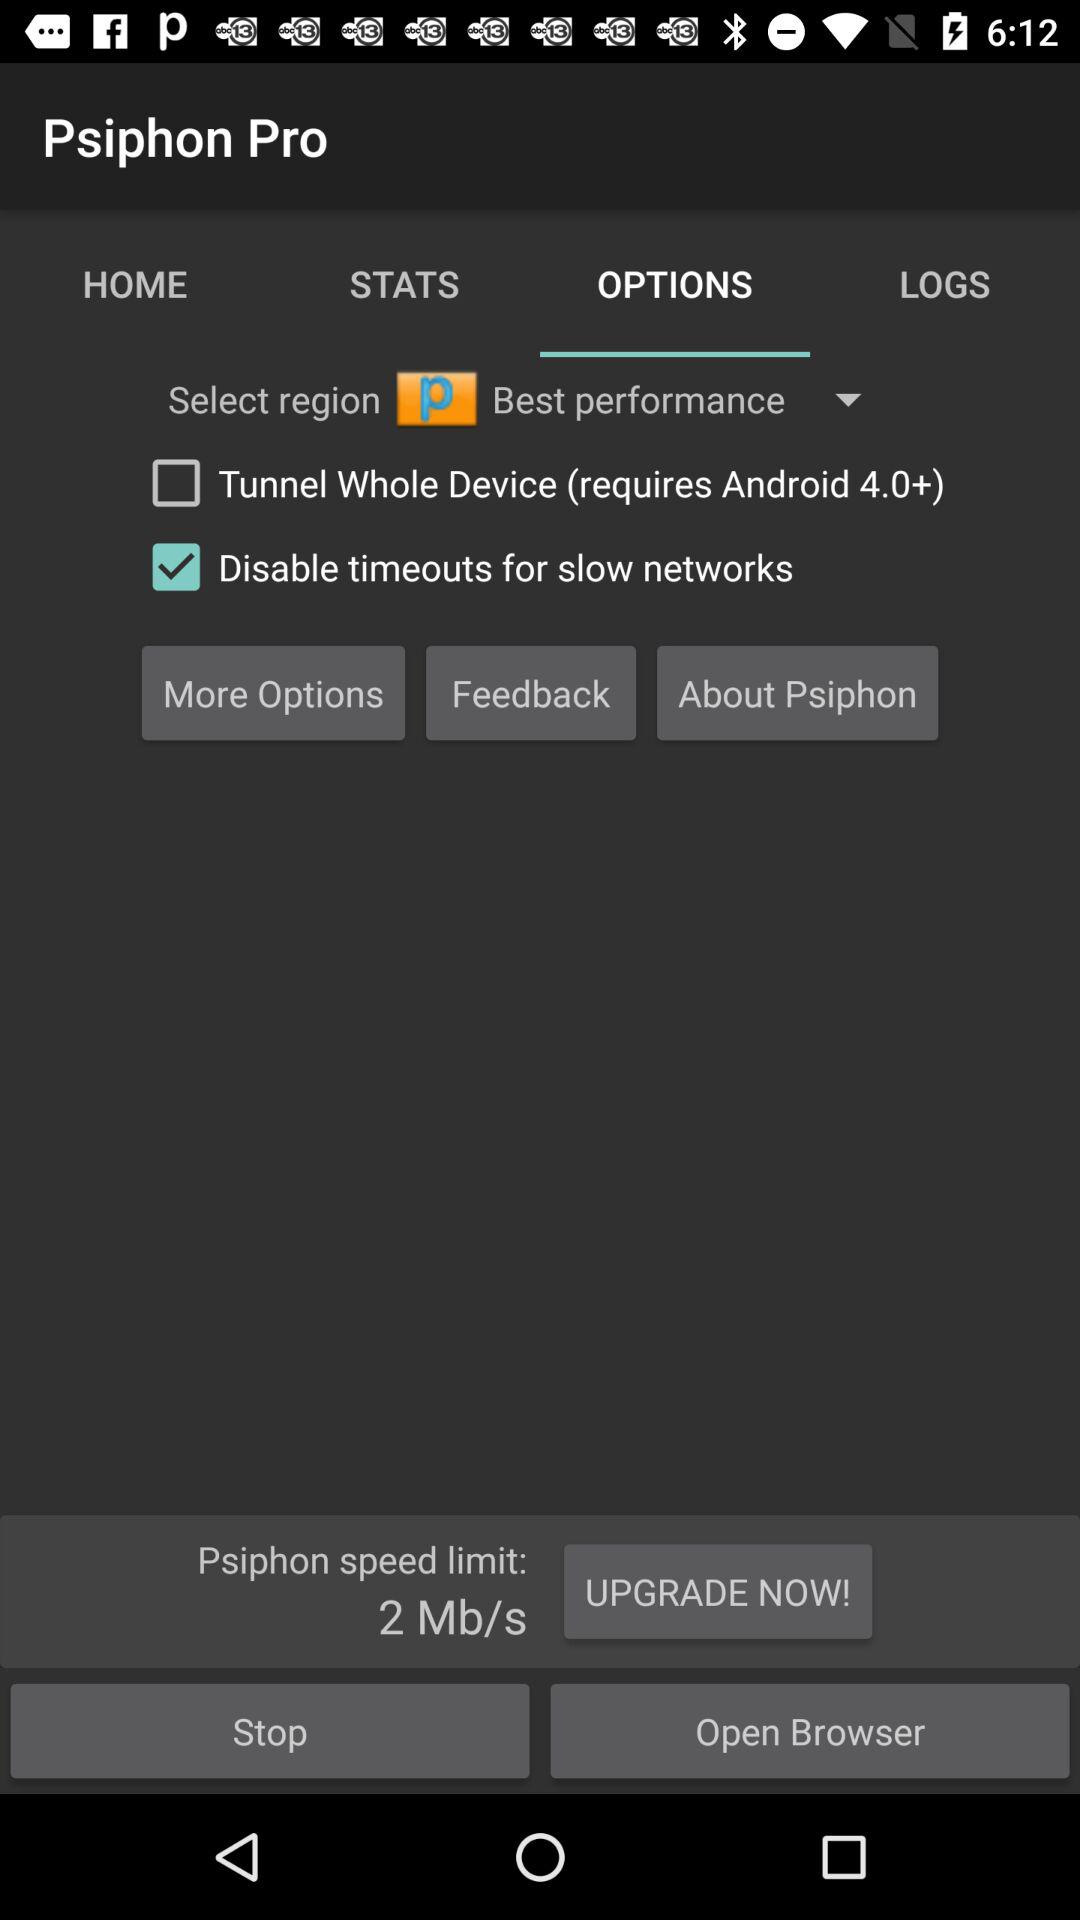What are the selected options? The selected options are "OPTIONS" and "Best performance". 